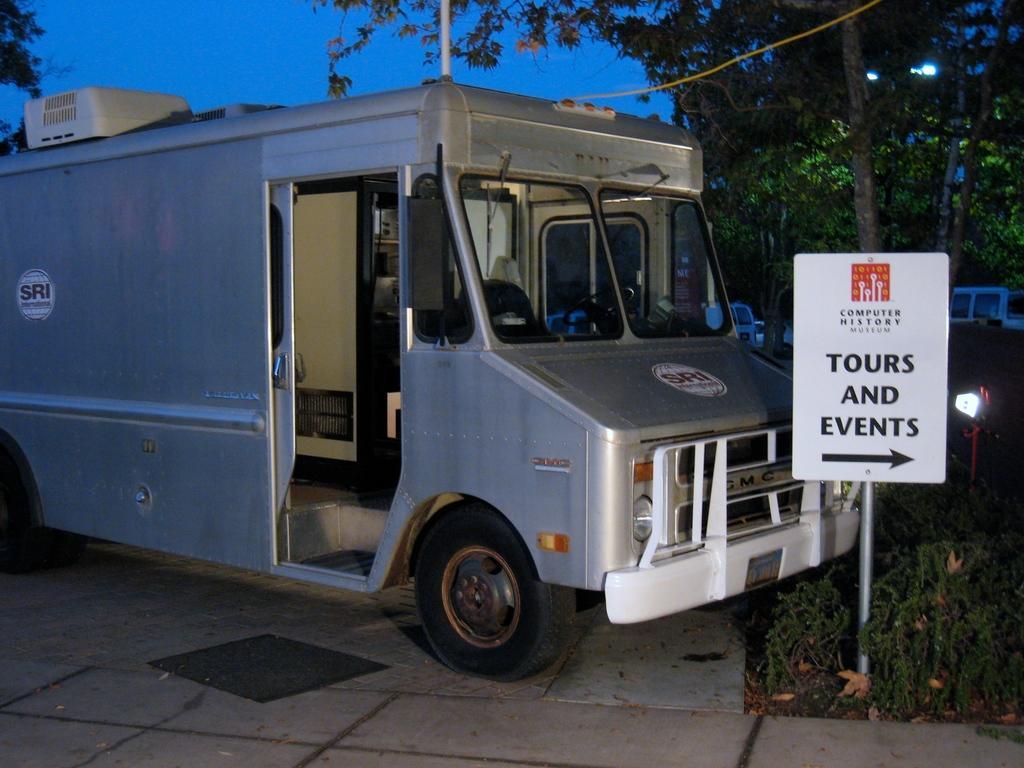Can you describe this image briefly? In this image I can see the ground, a pole and a white colored board to it and an ash colored vehicle on the ground. I can see few plants, few trees, few vehicles and the sky in the background. 